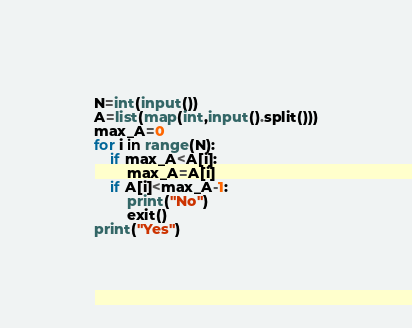<code> <loc_0><loc_0><loc_500><loc_500><_Python_>N=int(input())
A=list(map(int,input().split()))
max_A=0
for i in range(N):
    if max_A<A[i]:
        max_A=A[i]
    if A[i]<max_A-1:
        print("No")
        exit()
print("Yes")</code> 